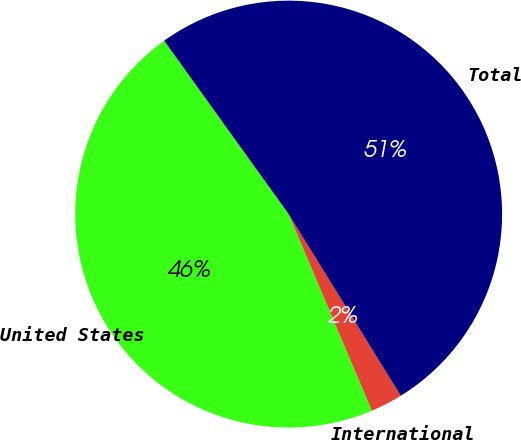Convert chart to OTSL. <chart><loc_0><loc_0><loc_500><loc_500><pie_chart><fcel>United States<fcel>International<fcel>Total<nl><fcel>46.46%<fcel>2.43%<fcel>51.11%<nl></chart> 